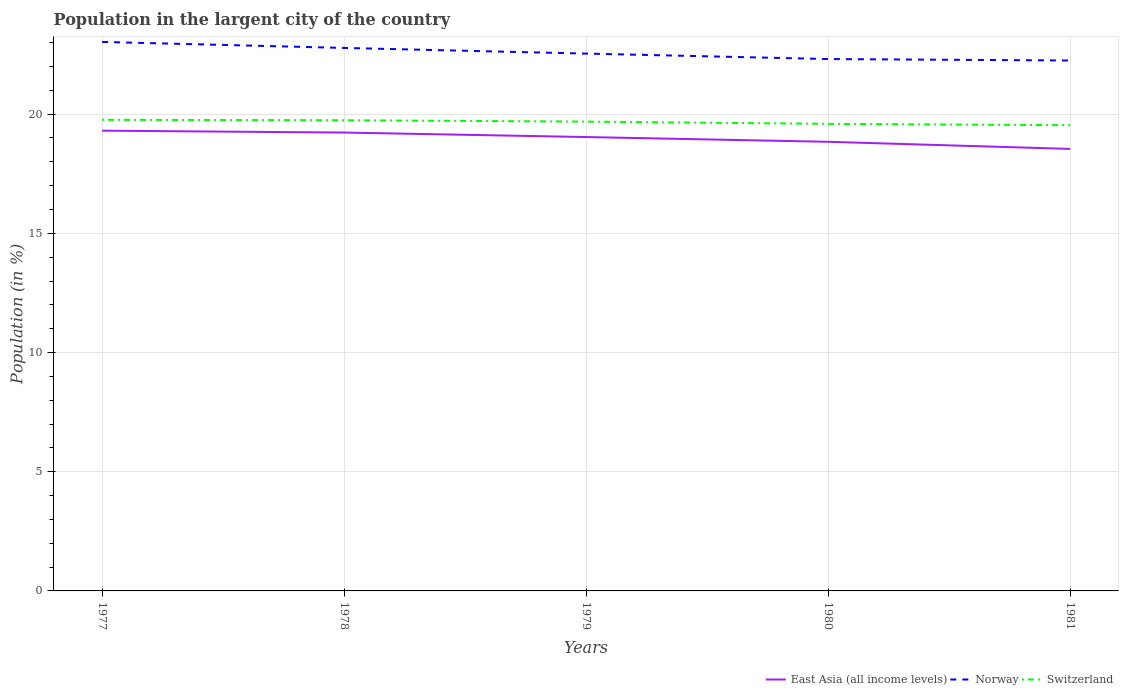Does the line corresponding to Norway intersect with the line corresponding to Switzerland?
Make the answer very short. No. Is the number of lines equal to the number of legend labels?
Offer a very short reply. Yes. Across all years, what is the maximum percentage of population in the largent city in Norway?
Your response must be concise. 22.25. What is the total percentage of population in the largent city in Norway in the graph?
Give a very brief answer. 0.78. What is the difference between the highest and the second highest percentage of population in the largent city in East Asia (all income levels)?
Make the answer very short. 0.77. Is the percentage of population in the largent city in East Asia (all income levels) strictly greater than the percentage of population in the largent city in Norway over the years?
Ensure brevity in your answer.  Yes. What is the difference between two consecutive major ticks on the Y-axis?
Make the answer very short. 5. Does the graph contain any zero values?
Your answer should be very brief. No. How are the legend labels stacked?
Provide a succinct answer. Horizontal. What is the title of the graph?
Your answer should be compact. Population in the largent city of the country. Does "East Asia (all income levels)" appear as one of the legend labels in the graph?
Your answer should be very brief. Yes. What is the label or title of the X-axis?
Give a very brief answer. Years. What is the Population (in %) of East Asia (all income levels) in 1977?
Ensure brevity in your answer.  19.31. What is the Population (in %) of Norway in 1977?
Your answer should be compact. 23.03. What is the Population (in %) in Switzerland in 1977?
Provide a succinct answer. 19.76. What is the Population (in %) in East Asia (all income levels) in 1978?
Offer a terse response. 19.23. What is the Population (in %) in Norway in 1978?
Provide a short and direct response. 22.78. What is the Population (in %) in Switzerland in 1978?
Offer a terse response. 19.74. What is the Population (in %) of East Asia (all income levels) in 1979?
Your response must be concise. 19.04. What is the Population (in %) in Norway in 1979?
Provide a short and direct response. 22.54. What is the Population (in %) in Switzerland in 1979?
Provide a short and direct response. 19.69. What is the Population (in %) of East Asia (all income levels) in 1980?
Provide a short and direct response. 18.84. What is the Population (in %) of Norway in 1980?
Your answer should be compact. 22.31. What is the Population (in %) in Switzerland in 1980?
Provide a succinct answer. 19.59. What is the Population (in %) in East Asia (all income levels) in 1981?
Ensure brevity in your answer.  18.54. What is the Population (in %) in Norway in 1981?
Ensure brevity in your answer.  22.25. What is the Population (in %) of Switzerland in 1981?
Offer a terse response. 19.54. Across all years, what is the maximum Population (in %) in East Asia (all income levels)?
Offer a terse response. 19.31. Across all years, what is the maximum Population (in %) of Norway?
Offer a terse response. 23.03. Across all years, what is the maximum Population (in %) in Switzerland?
Ensure brevity in your answer.  19.76. Across all years, what is the minimum Population (in %) in East Asia (all income levels)?
Keep it short and to the point. 18.54. Across all years, what is the minimum Population (in %) in Norway?
Provide a succinct answer. 22.25. Across all years, what is the minimum Population (in %) of Switzerland?
Your answer should be compact. 19.54. What is the total Population (in %) in East Asia (all income levels) in the graph?
Make the answer very short. 94.95. What is the total Population (in %) of Norway in the graph?
Ensure brevity in your answer.  112.9. What is the total Population (in %) of Switzerland in the graph?
Your answer should be compact. 98.32. What is the difference between the Population (in %) in East Asia (all income levels) in 1977 and that in 1978?
Offer a terse response. 0.08. What is the difference between the Population (in %) in Norway in 1977 and that in 1978?
Your response must be concise. 0.25. What is the difference between the Population (in %) of Switzerland in 1977 and that in 1978?
Provide a short and direct response. 0.02. What is the difference between the Population (in %) of East Asia (all income levels) in 1977 and that in 1979?
Ensure brevity in your answer.  0.27. What is the difference between the Population (in %) of Norway in 1977 and that in 1979?
Your answer should be compact. 0.49. What is the difference between the Population (in %) of Switzerland in 1977 and that in 1979?
Provide a succinct answer. 0.07. What is the difference between the Population (in %) in East Asia (all income levels) in 1977 and that in 1980?
Give a very brief answer. 0.47. What is the difference between the Population (in %) in Norway in 1977 and that in 1980?
Your answer should be compact. 0.72. What is the difference between the Population (in %) of Switzerland in 1977 and that in 1980?
Your answer should be compact. 0.17. What is the difference between the Population (in %) of East Asia (all income levels) in 1977 and that in 1981?
Give a very brief answer. 0.77. What is the difference between the Population (in %) of Norway in 1977 and that in 1981?
Ensure brevity in your answer.  0.78. What is the difference between the Population (in %) in Switzerland in 1977 and that in 1981?
Provide a succinct answer. 0.23. What is the difference between the Population (in %) in East Asia (all income levels) in 1978 and that in 1979?
Offer a terse response. 0.19. What is the difference between the Population (in %) of Norway in 1978 and that in 1979?
Your response must be concise. 0.24. What is the difference between the Population (in %) in Switzerland in 1978 and that in 1979?
Provide a short and direct response. 0.06. What is the difference between the Population (in %) of East Asia (all income levels) in 1978 and that in 1980?
Provide a succinct answer. 0.39. What is the difference between the Population (in %) of Norway in 1978 and that in 1980?
Offer a very short reply. 0.47. What is the difference between the Population (in %) in Switzerland in 1978 and that in 1980?
Offer a terse response. 0.15. What is the difference between the Population (in %) of East Asia (all income levels) in 1978 and that in 1981?
Your answer should be compact. 0.69. What is the difference between the Population (in %) in Norway in 1978 and that in 1981?
Ensure brevity in your answer.  0.53. What is the difference between the Population (in %) in Switzerland in 1978 and that in 1981?
Give a very brief answer. 0.21. What is the difference between the Population (in %) in East Asia (all income levels) in 1979 and that in 1980?
Make the answer very short. 0.2. What is the difference between the Population (in %) in Norway in 1979 and that in 1980?
Your response must be concise. 0.23. What is the difference between the Population (in %) of Switzerland in 1979 and that in 1980?
Keep it short and to the point. 0.09. What is the difference between the Population (in %) in East Asia (all income levels) in 1979 and that in 1981?
Ensure brevity in your answer.  0.5. What is the difference between the Population (in %) in Norway in 1979 and that in 1981?
Offer a terse response. 0.29. What is the difference between the Population (in %) of Switzerland in 1979 and that in 1981?
Offer a terse response. 0.15. What is the difference between the Population (in %) of East Asia (all income levels) in 1980 and that in 1981?
Your response must be concise. 0.3. What is the difference between the Population (in %) of Norway in 1980 and that in 1981?
Provide a short and direct response. 0.06. What is the difference between the Population (in %) in Switzerland in 1980 and that in 1981?
Provide a succinct answer. 0.06. What is the difference between the Population (in %) of East Asia (all income levels) in 1977 and the Population (in %) of Norway in 1978?
Your response must be concise. -3.47. What is the difference between the Population (in %) of East Asia (all income levels) in 1977 and the Population (in %) of Switzerland in 1978?
Ensure brevity in your answer.  -0.44. What is the difference between the Population (in %) of Norway in 1977 and the Population (in %) of Switzerland in 1978?
Your answer should be compact. 3.29. What is the difference between the Population (in %) in East Asia (all income levels) in 1977 and the Population (in %) in Norway in 1979?
Your answer should be very brief. -3.23. What is the difference between the Population (in %) of East Asia (all income levels) in 1977 and the Population (in %) of Switzerland in 1979?
Your response must be concise. -0.38. What is the difference between the Population (in %) of Norway in 1977 and the Population (in %) of Switzerland in 1979?
Ensure brevity in your answer.  3.34. What is the difference between the Population (in %) in East Asia (all income levels) in 1977 and the Population (in %) in Norway in 1980?
Make the answer very short. -3. What is the difference between the Population (in %) of East Asia (all income levels) in 1977 and the Population (in %) of Switzerland in 1980?
Give a very brief answer. -0.29. What is the difference between the Population (in %) of Norway in 1977 and the Population (in %) of Switzerland in 1980?
Offer a terse response. 3.44. What is the difference between the Population (in %) of East Asia (all income levels) in 1977 and the Population (in %) of Norway in 1981?
Give a very brief answer. -2.94. What is the difference between the Population (in %) of East Asia (all income levels) in 1977 and the Population (in %) of Switzerland in 1981?
Your answer should be compact. -0.23. What is the difference between the Population (in %) in Norway in 1977 and the Population (in %) in Switzerland in 1981?
Provide a succinct answer. 3.49. What is the difference between the Population (in %) of East Asia (all income levels) in 1978 and the Population (in %) of Norway in 1979?
Provide a succinct answer. -3.31. What is the difference between the Population (in %) of East Asia (all income levels) in 1978 and the Population (in %) of Switzerland in 1979?
Keep it short and to the point. -0.46. What is the difference between the Population (in %) of Norway in 1978 and the Population (in %) of Switzerland in 1979?
Your response must be concise. 3.09. What is the difference between the Population (in %) of East Asia (all income levels) in 1978 and the Population (in %) of Norway in 1980?
Offer a very short reply. -3.08. What is the difference between the Population (in %) in East Asia (all income levels) in 1978 and the Population (in %) in Switzerland in 1980?
Your answer should be very brief. -0.37. What is the difference between the Population (in %) of Norway in 1978 and the Population (in %) of Switzerland in 1980?
Your answer should be compact. 3.18. What is the difference between the Population (in %) in East Asia (all income levels) in 1978 and the Population (in %) in Norway in 1981?
Your answer should be very brief. -3.02. What is the difference between the Population (in %) of East Asia (all income levels) in 1978 and the Population (in %) of Switzerland in 1981?
Make the answer very short. -0.31. What is the difference between the Population (in %) in Norway in 1978 and the Population (in %) in Switzerland in 1981?
Offer a terse response. 3.24. What is the difference between the Population (in %) of East Asia (all income levels) in 1979 and the Population (in %) of Norway in 1980?
Your answer should be compact. -3.27. What is the difference between the Population (in %) in East Asia (all income levels) in 1979 and the Population (in %) in Switzerland in 1980?
Provide a short and direct response. -0.55. What is the difference between the Population (in %) of Norway in 1979 and the Population (in %) of Switzerland in 1980?
Give a very brief answer. 2.95. What is the difference between the Population (in %) of East Asia (all income levels) in 1979 and the Population (in %) of Norway in 1981?
Your response must be concise. -3.21. What is the difference between the Population (in %) in East Asia (all income levels) in 1979 and the Population (in %) in Switzerland in 1981?
Your answer should be very brief. -0.5. What is the difference between the Population (in %) of Norway in 1979 and the Population (in %) of Switzerland in 1981?
Your answer should be very brief. 3. What is the difference between the Population (in %) of East Asia (all income levels) in 1980 and the Population (in %) of Norway in 1981?
Give a very brief answer. -3.41. What is the difference between the Population (in %) of East Asia (all income levels) in 1980 and the Population (in %) of Switzerland in 1981?
Your response must be concise. -0.7. What is the difference between the Population (in %) in Norway in 1980 and the Population (in %) in Switzerland in 1981?
Keep it short and to the point. 2.77. What is the average Population (in %) of East Asia (all income levels) per year?
Give a very brief answer. 18.99. What is the average Population (in %) in Norway per year?
Make the answer very short. 22.58. What is the average Population (in %) of Switzerland per year?
Ensure brevity in your answer.  19.66. In the year 1977, what is the difference between the Population (in %) in East Asia (all income levels) and Population (in %) in Norway?
Your answer should be compact. -3.72. In the year 1977, what is the difference between the Population (in %) in East Asia (all income levels) and Population (in %) in Switzerland?
Provide a short and direct response. -0.46. In the year 1977, what is the difference between the Population (in %) in Norway and Population (in %) in Switzerland?
Provide a short and direct response. 3.27. In the year 1978, what is the difference between the Population (in %) in East Asia (all income levels) and Population (in %) in Norway?
Your response must be concise. -3.55. In the year 1978, what is the difference between the Population (in %) of East Asia (all income levels) and Population (in %) of Switzerland?
Your answer should be compact. -0.52. In the year 1978, what is the difference between the Population (in %) in Norway and Population (in %) in Switzerland?
Keep it short and to the point. 3.03. In the year 1979, what is the difference between the Population (in %) of East Asia (all income levels) and Population (in %) of Norway?
Your answer should be very brief. -3.5. In the year 1979, what is the difference between the Population (in %) in East Asia (all income levels) and Population (in %) in Switzerland?
Provide a short and direct response. -0.65. In the year 1979, what is the difference between the Population (in %) in Norway and Population (in %) in Switzerland?
Give a very brief answer. 2.85. In the year 1980, what is the difference between the Population (in %) in East Asia (all income levels) and Population (in %) in Norway?
Your answer should be very brief. -3.47. In the year 1980, what is the difference between the Population (in %) of East Asia (all income levels) and Population (in %) of Switzerland?
Provide a short and direct response. -0.75. In the year 1980, what is the difference between the Population (in %) in Norway and Population (in %) in Switzerland?
Offer a terse response. 2.72. In the year 1981, what is the difference between the Population (in %) of East Asia (all income levels) and Population (in %) of Norway?
Provide a short and direct response. -3.71. In the year 1981, what is the difference between the Population (in %) of East Asia (all income levels) and Population (in %) of Switzerland?
Offer a terse response. -0.99. In the year 1981, what is the difference between the Population (in %) of Norway and Population (in %) of Switzerland?
Keep it short and to the point. 2.71. What is the ratio of the Population (in %) in East Asia (all income levels) in 1977 to that in 1978?
Your response must be concise. 1. What is the ratio of the Population (in %) in Norway in 1977 to that in 1978?
Your response must be concise. 1.01. What is the ratio of the Population (in %) of East Asia (all income levels) in 1977 to that in 1979?
Your answer should be compact. 1.01. What is the ratio of the Population (in %) of Norway in 1977 to that in 1979?
Your answer should be very brief. 1.02. What is the ratio of the Population (in %) in Switzerland in 1977 to that in 1979?
Your answer should be compact. 1. What is the ratio of the Population (in %) in East Asia (all income levels) in 1977 to that in 1980?
Your answer should be compact. 1.02. What is the ratio of the Population (in %) of Norway in 1977 to that in 1980?
Offer a terse response. 1.03. What is the ratio of the Population (in %) of Switzerland in 1977 to that in 1980?
Ensure brevity in your answer.  1.01. What is the ratio of the Population (in %) of East Asia (all income levels) in 1977 to that in 1981?
Offer a very short reply. 1.04. What is the ratio of the Population (in %) of Norway in 1977 to that in 1981?
Your answer should be compact. 1.03. What is the ratio of the Population (in %) of Switzerland in 1977 to that in 1981?
Ensure brevity in your answer.  1.01. What is the ratio of the Population (in %) in East Asia (all income levels) in 1978 to that in 1979?
Offer a very short reply. 1.01. What is the ratio of the Population (in %) in Norway in 1978 to that in 1979?
Offer a very short reply. 1.01. What is the ratio of the Population (in %) in East Asia (all income levels) in 1978 to that in 1980?
Keep it short and to the point. 1.02. What is the ratio of the Population (in %) of Norway in 1978 to that in 1980?
Ensure brevity in your answer.  1.02. What is the ratio of the Population (in %) in Switzerland in 1978 to that in 1980?
Offer a terse response. 1.01. What is the ratio of the Population (in %) in Norway in 1978 to that in 1981?
Keep it short and to the point. 1.02. What is the ratio of the Population (in %) of Switzerland in 1978 to that in 1981?
Your answer should be very brief. 1.01. What is the ratio of the Population (in %) in East Asia (all income levels) in 1979 to that in 1980?
Give a very brief answer. 1.01. What is the ratio of the Population (in %) in Norway in 1979 to that in 1980?
Keep it short and to the point. 1.01. What is the ratio of the Population (in %) of Switzerland in 1979 to that in 1980?
Provide a short and direct response. 1. What is the ratio of the Population (in %) in East Asia (all income levels) in 1979 to that in 1981?
Make the answer very short. 1.03. What is the ratio of the Population (in %) of Switzerland in 1979 to that in 1981?
Give a very brief answer. 1.01. What is the ratio of the Population (in %) in East Asia (all income levels) in 1980 to that in 1981?
Offer a very short reply. 1.02. What is the ratio of the Population (in %) of Norway in 1980 to that in 1981?
Your answer should be very brief. 1. What is the difference between the highest and the second highest Population (in %) in East Asia (all income levels)?
Provide a short and direct response. 0.08. What is the difference between the highest and the second highest Population (in %) in Norway?
Provide a short and direct response. 0.25. What is the difference between the highest and the second highest Population (in %) of Switzerland?
Your answer should be compact. 0.02. What is the difference between the highest and the lowest Population (in %) in East Asia (all income levels)?
Provide a short and direct response. 0.77. What is the difference between the highest and the lowest Population (in %) of Norway?
Provide a short and direct response. 0.78. What is the difference between the highest and the lowest Population (in %) in Switzerland?
Ensure brevity in your answer.  0.23. 